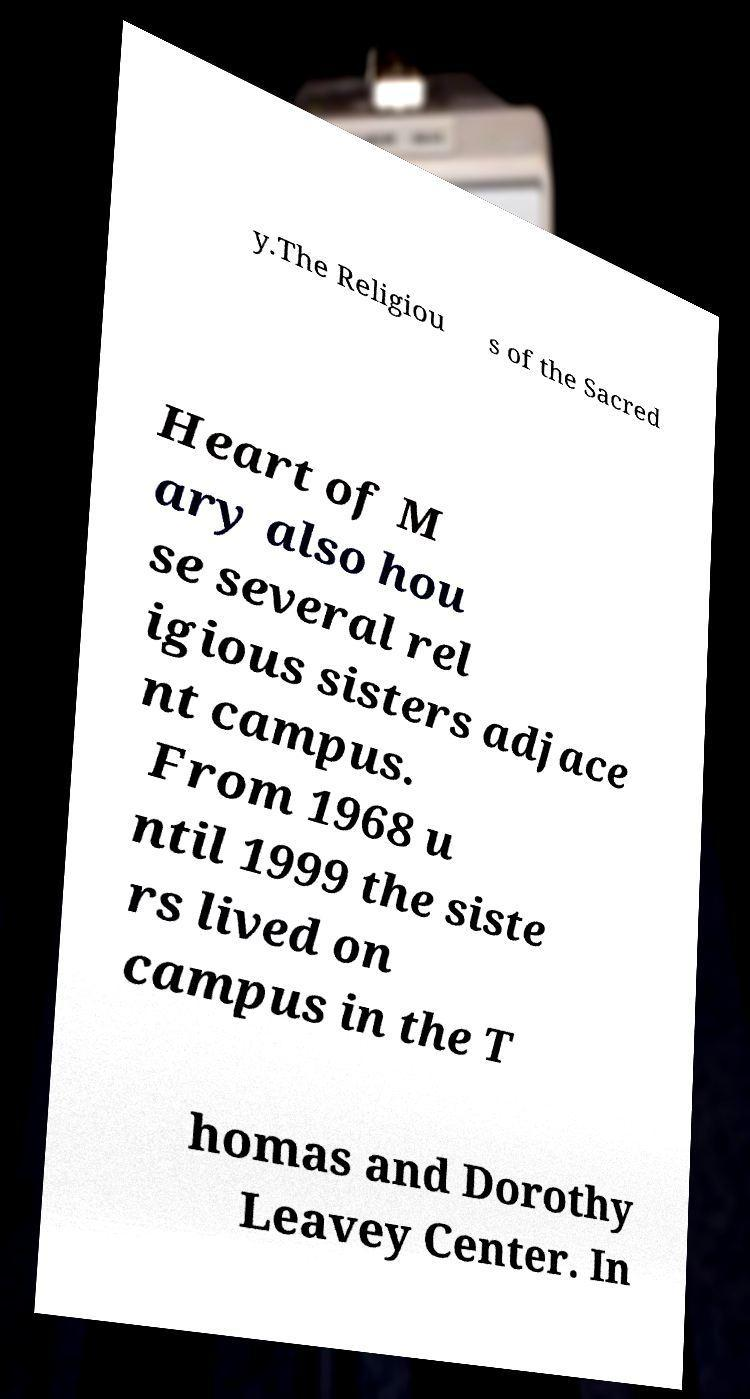Please read and relay the text visible in this image. What does it say? y.The Religiou s of the Sacred Heart of M ary also hou se several rel igious sisters adjace nt campus. From 1968 u ntil 1999 the siste rs lived on campus in the T homas and Dorothy Leavey Center. In 